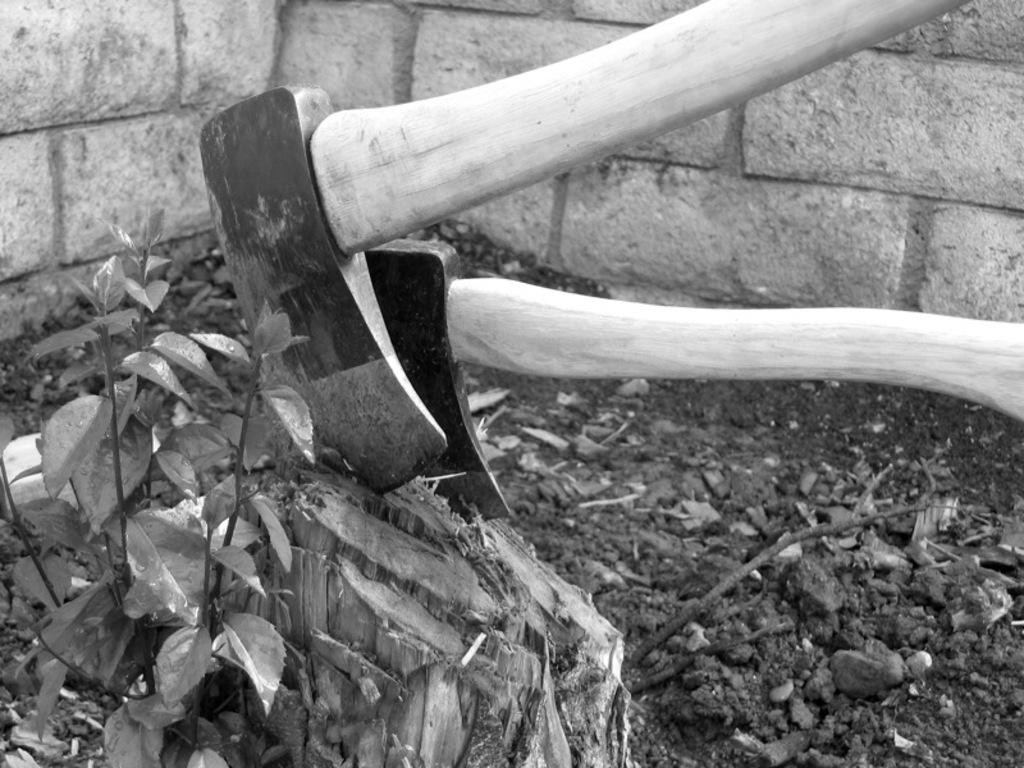What objects are present in the image that can be used for cutting? There are axes in the image that can be used for cutting. What type of object can be seen made of wood? There is a wooden object in the image. What living organism is present in the image? There is a plant in the image. What type of material is on the ground in the image? There are sticks on the ground in the image. What can be seen in the background of the image? There is a wall in the background of the image. What type of dust can be seen covering the axes in the image? There is no dust visible on the axes in the image. What can be used to store the plant in the image? The image does not show any cans or containers for storing the plant. 